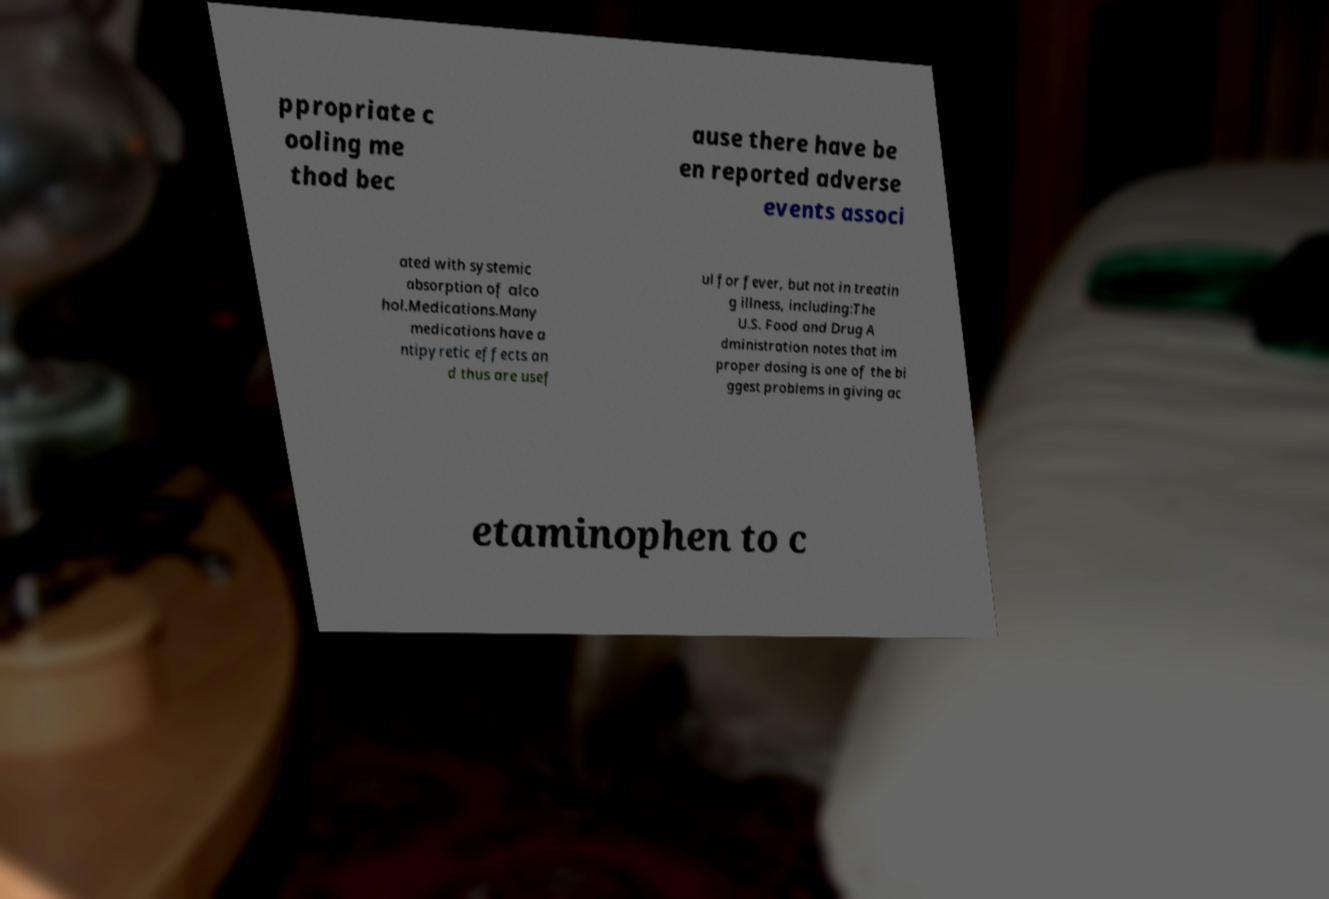I need the written content from this picture converted into text. Can you do that? ppropriate c ooling me thod bec ause there have be en reported adverse events associ ated with systemic absorption of alco hol.Medications.Many medications have a ntipyretic effects an d thus are usef ul for fever, but not in treatin g illness, including:The U.S. Food and Drug A dministration notes that im proper dosing is one of the bi ggest problems in giving ac etaminophen to c 